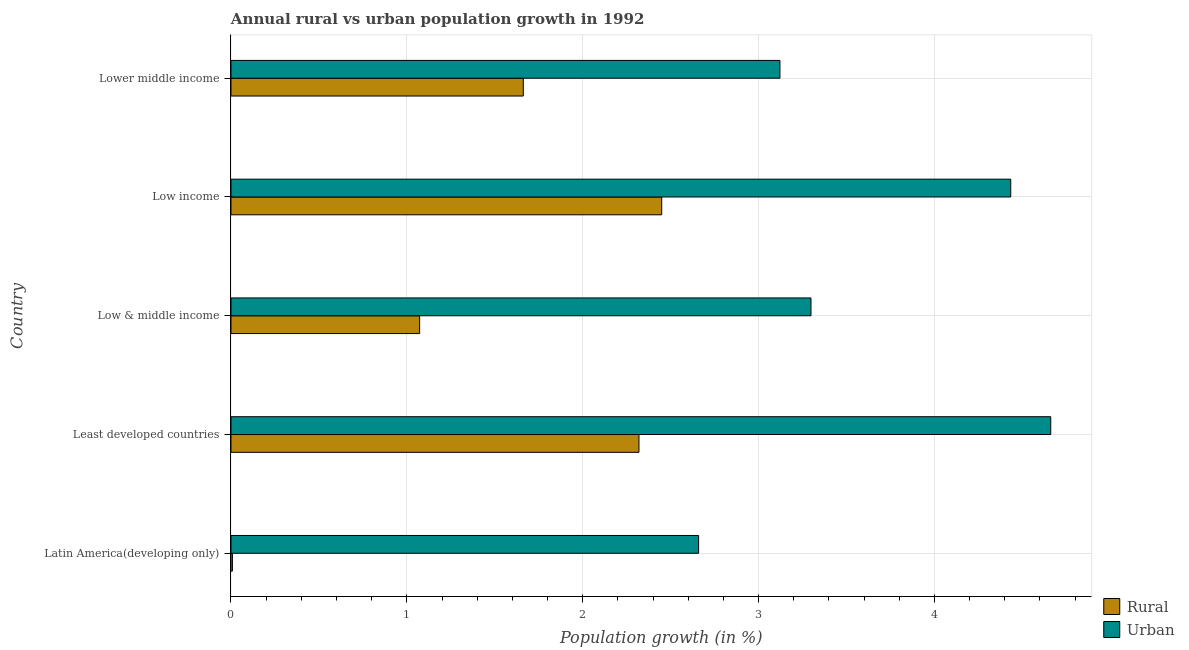How many different coloured bars are there?
Your answer should be very brief. 2. Are the number of bars per tick equal to the number of legend labels?
Your answer should be compact. Yes. Are the number of bars on each tick of the Y-axis equal?
Your answer should be compact. Yes. How many bars are there on the 4th tick from the top?
Provide a short and direct response. 2. What is the label of the 5th group of bars from the top?
Give a very brief answer. Latin America(developing only). What is the rural population growth in Least developed countries?
Give a very brief answer. 2.32. Across all countries, what is the maximum urban population growth?
Your answer should be compact. 4.66. Across all countries, what is the minimum rural population growth?
Provide a succinct answer. 0.01. In which country was the urban population growth minimum?
Give a very brief answer. Latin America(developing only). What is the total rural population growth in the graph?
Make the answer very short. 7.51. What is the difference between the urban population growth in Low & middle income and that in Lower middle income?
Offer a very short reply. 0.18. What is the difference between the rural population growth in Least developed countries and the urban population growth in Lower middle income?
Your answer should be compact. -0.8. What is the average rural population growth per country?
Your answer should be very brief. 1.5. What is the difference between the rural population growth and urban population growth in Least developed countries?
Make the answer very short. -2.34. In how many countries, is the urban population growth greater than 1.4 %?
Provide a succinct answer. 5. What is the ratio of the urban population growth in Latin America(developing only) to that in Low & middle income?
Make the answer very short. 0.81. What is the difference between the highest and the second highest rural population growth?
Offer a terse response. 0.13. What is the difference between the highest and the lowest rural population growth?
Ensure brevity in your answer.  2.44. In how many countries, is the rural population growth greater than the average rural population growth taken over all countries?
Keep it short and to the point. 3. What does the 1st bar from the top in Low & middle income represents?
Keep it short and to the point. Urban . What does the 2nd bar from the bottom in Low & middle income represents?
Provide a succinct answer. Urban . Are all the bars in the graph horizontal?
Offer a very short reply. Yes. How many countries are there in the graph?
Ensure brevity in your answer.  5. What is the difference between two consecutive major ticks on the X-axis?
Your answer should be compact. 1. Does the graph contain any zero values?
Keep it short and to the point. No. Does the graph contain grids?
Provide a short and direct response. Yes. Where does the legend appear in the graph?
Ensure brevity in your answer.  Bottom right. How are the legend labels stacked?
Make the answer very short. Vertical. What is the title of the graph?
Your response must be concise. Annual rural vs urban population growth in 1992. Does "Start a business" appear as one of the legend labels in the graph?
Offer a terse response. No. What is the label or title of the X-axis?
Make the answer very short. Population growth (in %). What is the label or title of the Y-axis?
Offer a very short reply. Country. What is the Population growth (in %) in Rural in Latin America(developing only)?
Keep it short and to the point. 0.01. What is the Population growth (in %) in Urban  in Latin America(developing only)?
Provide a succinct answer. 2.66. What is the Population growth (in %) in Rural in Least developed countries?
Your answer should be compact. 2.32. What is the Population growth (in %) in Urban  in Least developed countries?
Your answer should be very brief. 4.66. What is the Population growth (in %) in Rural in Low & middle income?
Make the answer very short. 1.07. What is the Population growth (in %) of Urban  in Low & middle income?
Offer a very short reply. 3.3. What is the Population growth (in %) in Rural in Low income?
Give a very brief answer. 2.45. What is the Population growth (in %) of Urban  in Low income?
Make the answer very short. 4.43. What is the Population growth (in %) in Rural in Lower middle income?
Your answer should be very brief. 1.66. What is the Population growth (in %) in Urban  in Lower middle income?
Offer a very short reply. 3.12. Across all countries, what is the maximum Population growth (in %) of Rural?
Ensure brevity in your answer.  2.45. Across all countries, what is the maximum Population growth (in %) of Urban ?
Your response must be concise. 4.66. Across all countries, what is the minimum Population growth (in %) of Rural?
Keep it short and to the point. 0.01. Across all countries, what is the minimum Population growth (in %) in Urban ?
Offer a very short reply. 2.66. What is the total Population growth (in %) of Rural in the graph?
Provide a succinct answer. 7.51. What is the total Population growth (in %) in Urban  in the graph?
Your response must be concise. 18.17. What is the difference between the Population growth (in %) in Rural in Latin America(developing only) and that in Least developed countries?
Ensure brevity in your answer.  -2.31. What is the difference between the Population growth (in %) in Urban  in Latin America(developing only) and that in Least developed countries?
Your answer should be very brief. -2. What is the difference between the Population growth (in %) of Rural in Latin America(developing only) and that in Low & middle income?
Offer a terse response. -1.06. What is the difference between the Population growth (in %) in Urban  in Latin America(developing only) and that in Low & middle income?
Your response must be concise. -0.64. What is the difference between the Population growth (in %) of Rural in Latin America(developing only) and that in Low income?
Offer a very short reply. -2.44. What is the difference between the Population growth (in %) in Urban  in Latin America(developing only) and that in Low income?
Keep it short and to the point. -1.77. What is the difference between the Population growth (in %) in Rural in Latin America(developing only) and that in Lower middle income?
Your answer should be compact. -1.65. What is the difference between the Population growth (in %) of Urban  in Latin America(developing only) and that in Lower middle income?
Offer a terse response. -0.46. What is the difference between the Population growth (in %) in Rural in Least developed countries and that in Low & middle income?
Offer a very short reply. 1.25. What is the difference between the Population growth (in %) in Urban  in Least developed countries and that in Low & middle income?
Ensure brevity in your answer.  1.36. What is the difference between the Population growth (in %) of Rural in Least developed countries and that in Low income?
Offer a terse response. -0.13. What is the difference between the Population growth (in %) in Urban  in Least developed countries and that in Low income?
Offer a terse response. 0.23. What is the difference between the Population growth (in %) of Rural in Least developed countries and that in Lower middle income?
Your answer should be very brief. 0.66. What is the difference between the Population growth (in %) of Urban  in Least developed countries and that in Lower middle income?
Give a very brief answer. 1.54. What is the difference between the Population growth (in %) of Rural in Low & middle income and that in Low income?
Provide a short and direct response. -1.38. What is the difference between the Population growth (in %) in Urban  in Low & middle income and that in Low income?
Give a very brief answer. -1.14. What is the difference between the Population growth (in %) of Rural in Low & middle income and that in Lower middle income?
Ensure brevity in your answer.  -0.59. What is the difference between the Population growth (in %) in Urban  in Low & middle income and that in Lower middle income?
Give a very brief answer. 0.18. What is the difference between the Population growth (in %) in Rural in Low income and that in Lower middle income?
Make the answer very short. 0.79. What is the difference between the Population growth (in %) of Urban  in Low income and that in Lower middle income?
Provide a succinct answer. 1.31. What is the difference between the Population growth (in %) of Rural in Latin America(developing only) and the Population growth (in %) of Urban  in Least developed countries?
Offer a terse response. -4.65. What is the difference between the Population growth (in %) of Rural in Latin America(developing only) and the Population growth (in %) of Urban  in Low & middle income?
Give a very brief answer. -3.29. What is the difference between the Population growth (in %) in Rural in Latin America(developing only) and the Population growth (in %) in Urban  in Low income?
Keep it short and to the point. -4.43. What is the difference between the Population growth (in %) in Rural in Latin America(developing only) and the Population growth (in %) in Urban  in Lower middle income?
Ensure brevity in your answer.  -3.11. What is the difference between the Population growth (in %) of Rural in Least developed countries and the Population growth (in %) of Urban  in Low & middle income?
Your answer should be very brief. -0.98. What is the difference between the Population growth (in %) of Rural in Least developed countries and the Population growth (in %) of Urban  in Low income?
Provide a short and direct response. -2.11. What is the difference between the Population growth (in %) of Rural in Least developed countries and the Population growth (in %) of Urban  in Lower middle income?
Ensure brevity in your answer.  -0.8. What is the difference between the Population growth (in %) in Rural in Low & middle income and the Population growth (in %) in Urban  in Low income?
Offer a very short reply. -3.36. What is the difference between the Population growth (in %) in Rural in Low & middle income and the Population growth (in %) in Urban  in Lower middle income?
Provide a succinct answer. -2.05. What is the difference between the Population growth (in %) of Rural in Low income and the Population growth (in %) of Urban  in Lower middle income?
Ensure brevity in your answer.  -0.67. What is the average Population growth (in %) in Rural per country?
Ensure brevity in your answer.  1.5. What is the average Population growth (in %) in Urban  per country?
Provide a short and direct response. 3.63. What is the difference between the Population growth (in %) in Rural and Population growth (in %) in Urban  in Latin America(developing only)?
Offer a very short reply. -2.65. What is the difference between the Population growth (in %) in Rural and Population growth (in %) in Urban  in Least developed countries?
Offer a terse response. -2.34. What is the difference between the Population growth (in %) of Rural and Population growth (in %) of Urban  in Low & middle income?
Your answer should be compact. -2.23. What is the difference between the Population growth (in %) of Rural and Population growth (in %) of Urban  in Low income?
Provide a succinct answer. -1.98. What is the difference between the Population growth (in %) in Rural and Population growth (in %) in Urban  in Lower middle income?
Offer a terse response. -1.46. What is the ratio of the Population growth (in %) in Rural in Latin America(developing only) to that in Least developed countries?
Keep it short and to the point. 0. What is the ratio of the Population growth (in %) in Urban  in Latin America(developing only) to that in Least developed countries?
Your answer should be very brief. 0.57. What is the ratio of the Population growth (in %) in Rural in Latin America(developing only) to that in Low & middle income?
Make the answer very short. 0.01. What is the ratio of the Population growth (in %) in Urban  in Latin America(developing only) to that in Low & middle income?
Your response must be concise. 0.81. What is the ratio of the Population growth (in %) of Rural in Latin America(developing only) to that in Low income?
Your response must be concise. 0. What is the ratio of the Population growth (in %) of Urban  in Latin America(developing only) to that in Low income?
Your answer should be very brief. 0.6. What is the ratio of the Population growth (in %) in Rural in Latin America(developing only) to that in Lower middle income?
Offer a very short reply. 0. What is the ratio of the Population growth (in %) of Urban  in Latin America(developing only) to that in Lower middle income?
Provide a succinct answer. 0.85. What is the ratio of the Population growth (in %) of Rural in Least developed countries to that in Low & middle income?
Your answer should be compact. 2.16. What is the ratio of the Population growth (in %) of Urban  in Least developed countries to that in Low & middle income?
Your response must be concise. 1.41. What is the ratio of the Population growth (in %) of Rural in Least developed countries to that in Low income?
Your answer should be very brief. 0.95. What is the ratio of the Population growth (in %) in Urban  in Least developed countries to that in Low income?
Your answer should be compact. 1.05. What is the ratio of the Population growth (in %) in Rural in Least developed countries to that in Lower middle income?
Provide a succinct answer. 1.4. What is the ratio of the Population growth (in %) in Urban  in Least developed countries to that in Lower middle income?
Make the answer very short. 1.49. What is the ratio of the Population growth (in %) of Rural in Low & middle income to that in Low income?
Provide a succinct answer. 0.44. What is the ratio of the Population growth (in %) of Urban  in Low & middle income to that in Low income?
Keep it short and to the point. 0.74. What is the ratio of the Population growth (in %) in Rural in Low & middle income to that in Lower middle income?
Keep it short and to the point. 0.65. What is the ratio of the Population growth (in %) in Urban  in Low & middle income to that in Lower middle income?
Offer a very short reply. 1.06. What is the ratio of the Population growth (in %) of Rural in Low income to that in Lower middle income?
Offer a terse response. 1.47. What is the ratio of the Population growth (in %) in Urban  in Low income to that in Lower middle income?
Provide a succinct answer. 1.42. What is the difference between the highest and the second highest Population growth (in %) of Rural?
Offer a very short reply. 0.13. What is the difference between the highest and the second highest Population growth (in %) of Urban ?
Offer a terse response. 0.23. What is the difference between the highest and the lowest Population growth (in %) of Rural?
Keep it short and to the point. 2.44. What is the difference between the highest and the lowest Population growth (in %) in Urban ?
Your answer should be very brief. 2. 